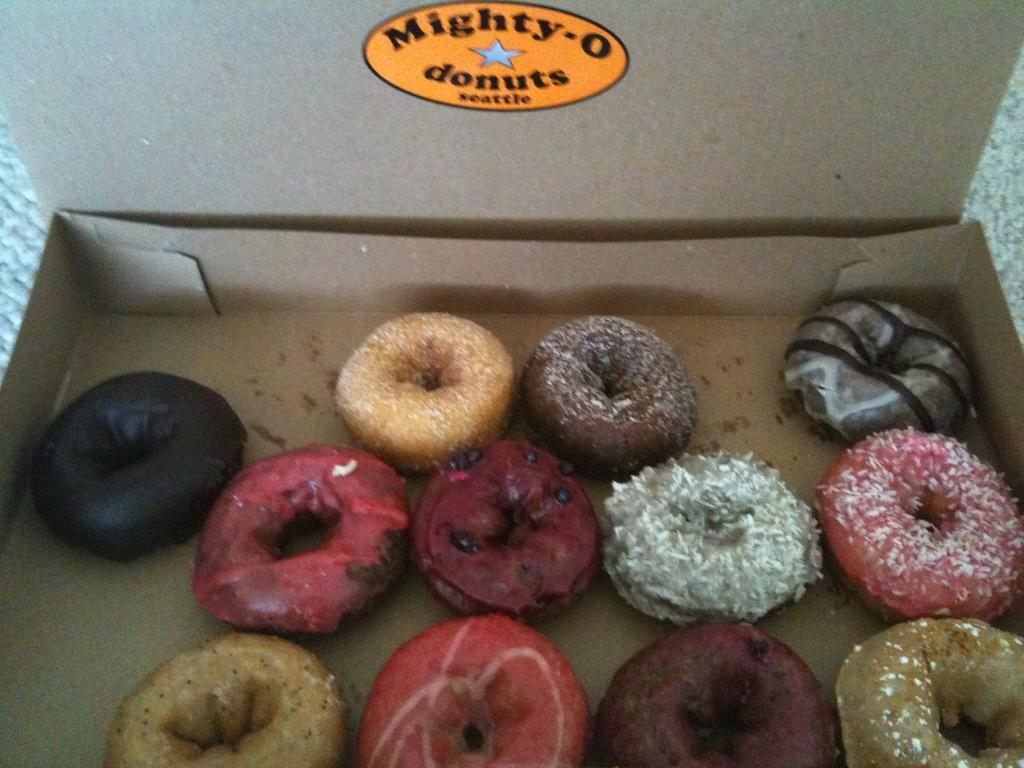What type of food is visible in the image? There are different types of doughnuts in the image. How are the doughnuts contained in the image? The doughnuts are in a box. What is the box resting on in the image? The box is on a cloth-like object. What type of government is depicted in the image? There is no depiction of a government in the image; it features doughnuts in a box on a cloth-like object. What type of apparel is visible on the doughnuts in the image? The doughnuts do not have any apparel; they are simply doughnuts in a box. 